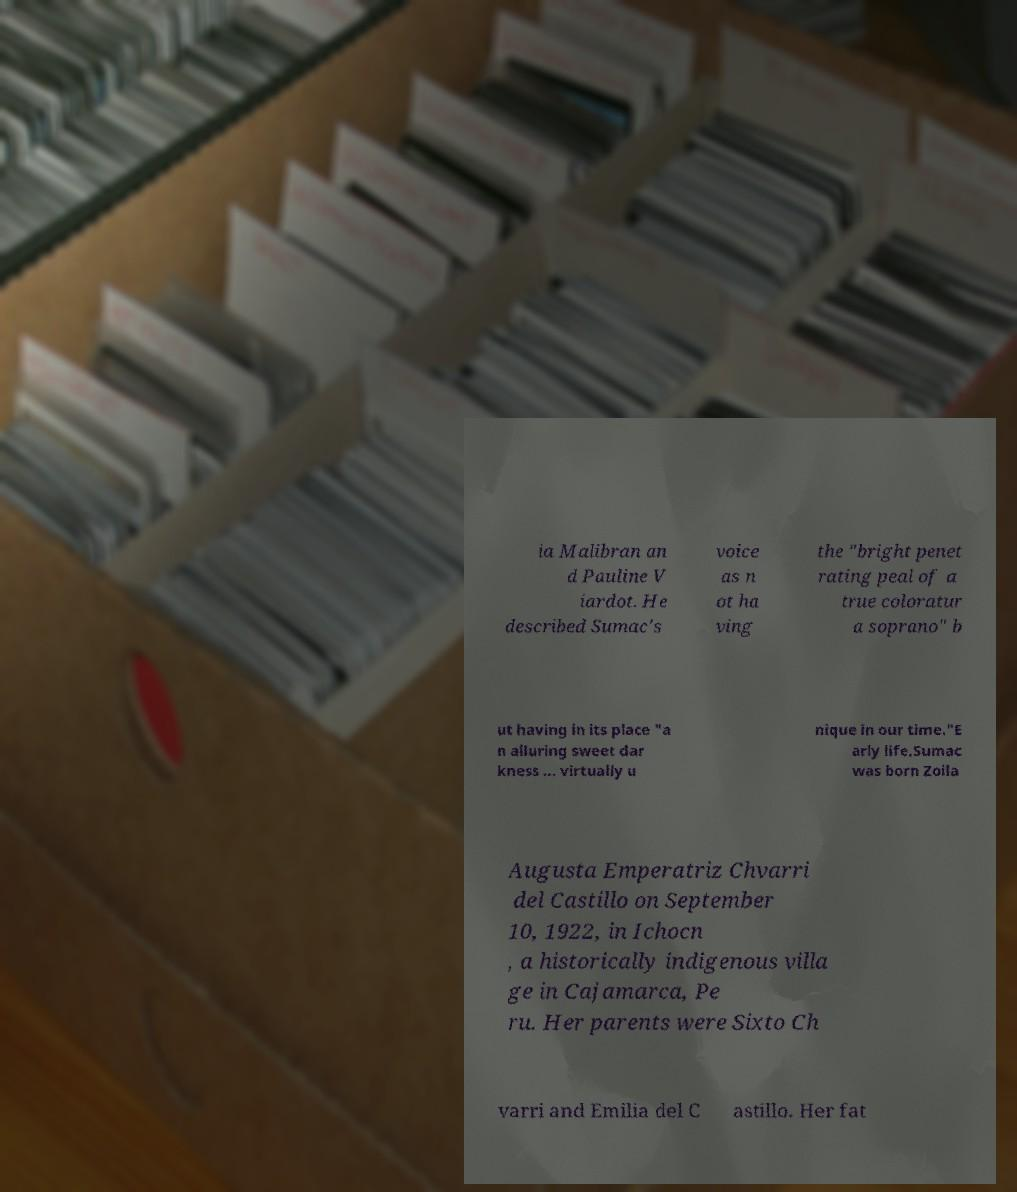Could you assist in decoding the text presented in this image and type it out clearly? ia Malibran an d Pauline V iardot. He described Sumac's voice as n ot ha ving the "bright penet rating peal of a true coloratur a soprano" b ut having in its place "a n alluring sweet dar kness ... virtually u nique in our time."E arly life.Sumac was born Zoila Augusta Emperatriz Chvarri del Castillo on September 10, 1922, in Ichocn , a historically indigenous villa ge in Cajamarca, Pe ru. Her parents were Sixto Ch varri and Emilia del C astillo. Her fat 